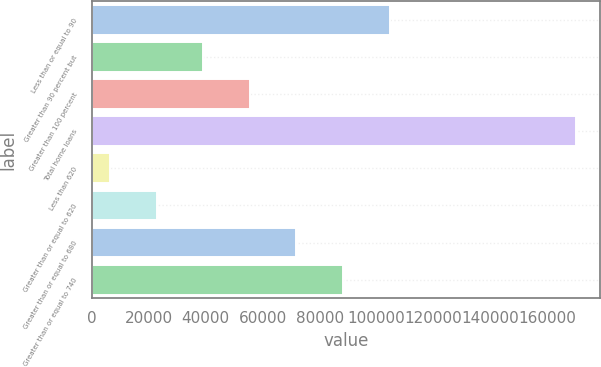Convert chart. <chart><loc_0><loc_0><loc_500><loc_500><bar_chart><fcel>Less than or equal to 90<fcel>Greater than 90 percent but<fcel>Greater than 100 percent<fcel>Total home loans<fcel>Less than 620<fcel>Greater than or equal to 620<fcel>Greater than or equal to 680<fcel>Greater than or equal to 740<nl><fcel>104616<fcel>39116<fcel>55491<fcel>170116<fcel>6366<fcel>22741<fcel>71866<fcel>88241<nl></chart> 